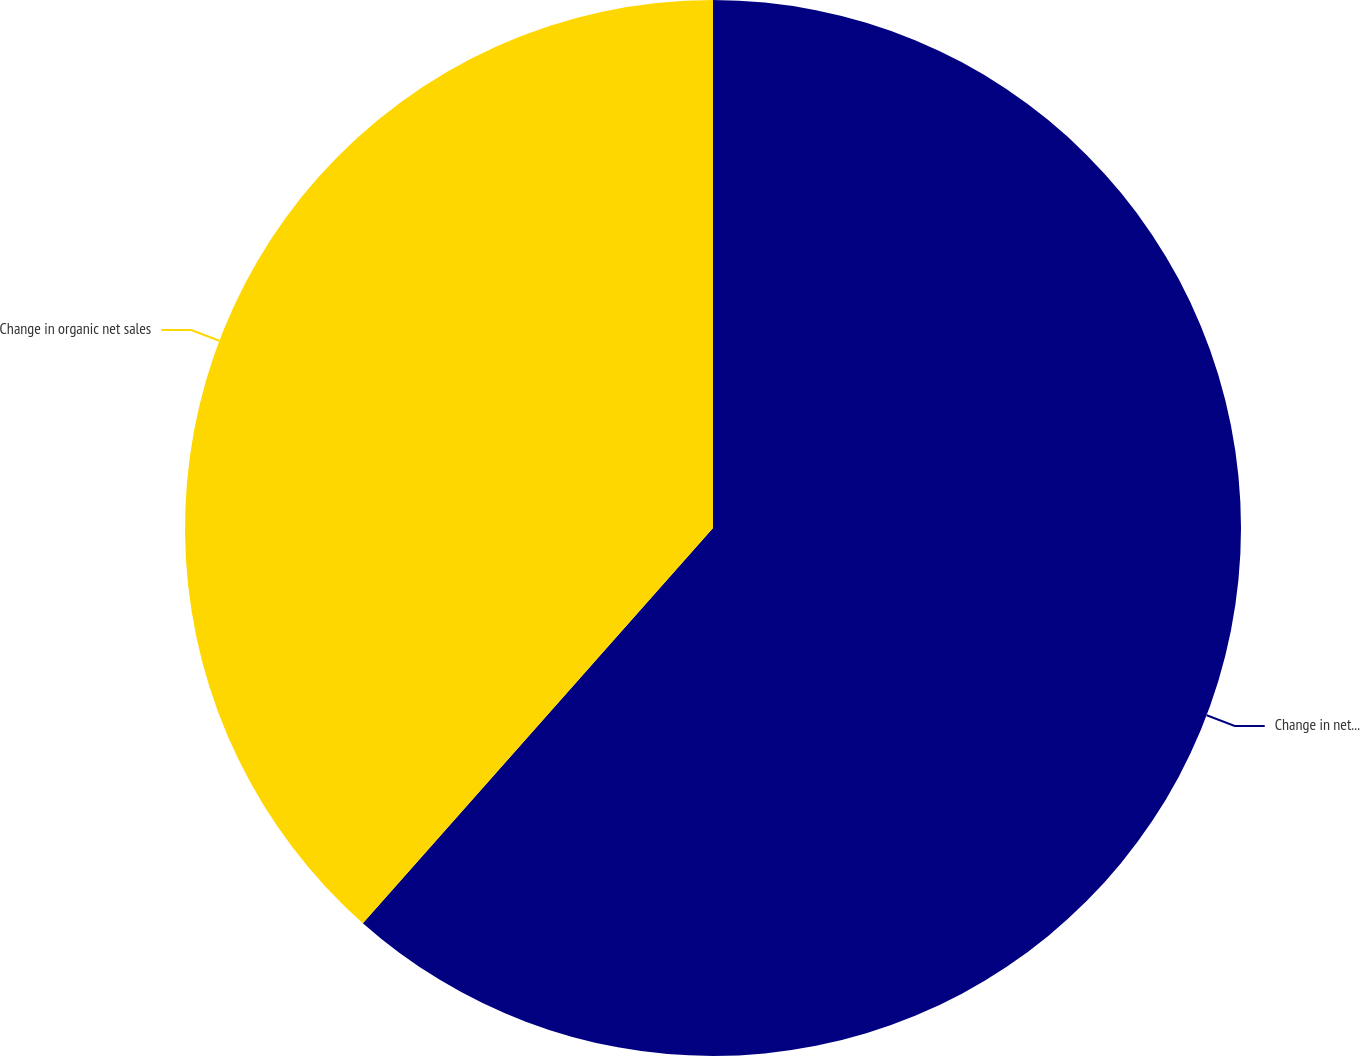<chart> <loc_0><loc_0><loc_500><loc_500><pie_chart><fcel>Change in net sales<fcel>Change in organic net sales<nl><fcel>61.54%<fcel>38.46%<nl></chart> 